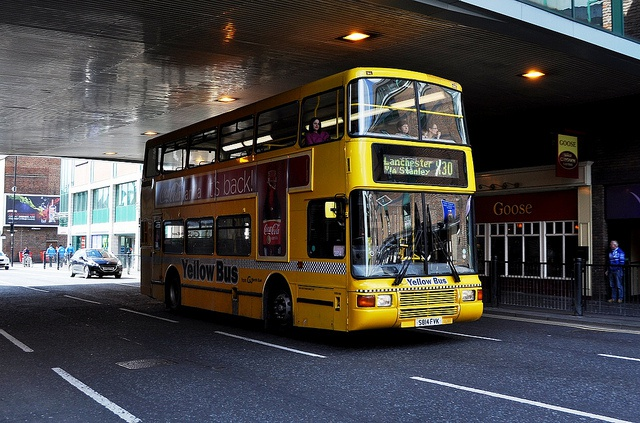Describe the objects in this image and their specific colors. I can see bus in black, maroon, gray, and olive tones, car in black, white, darkgray, and gray tones, people in black, navy, darkblue, and gray tones, people in black, purple, and gray tones, and people in black, gray, and darkgray tones in this image. 